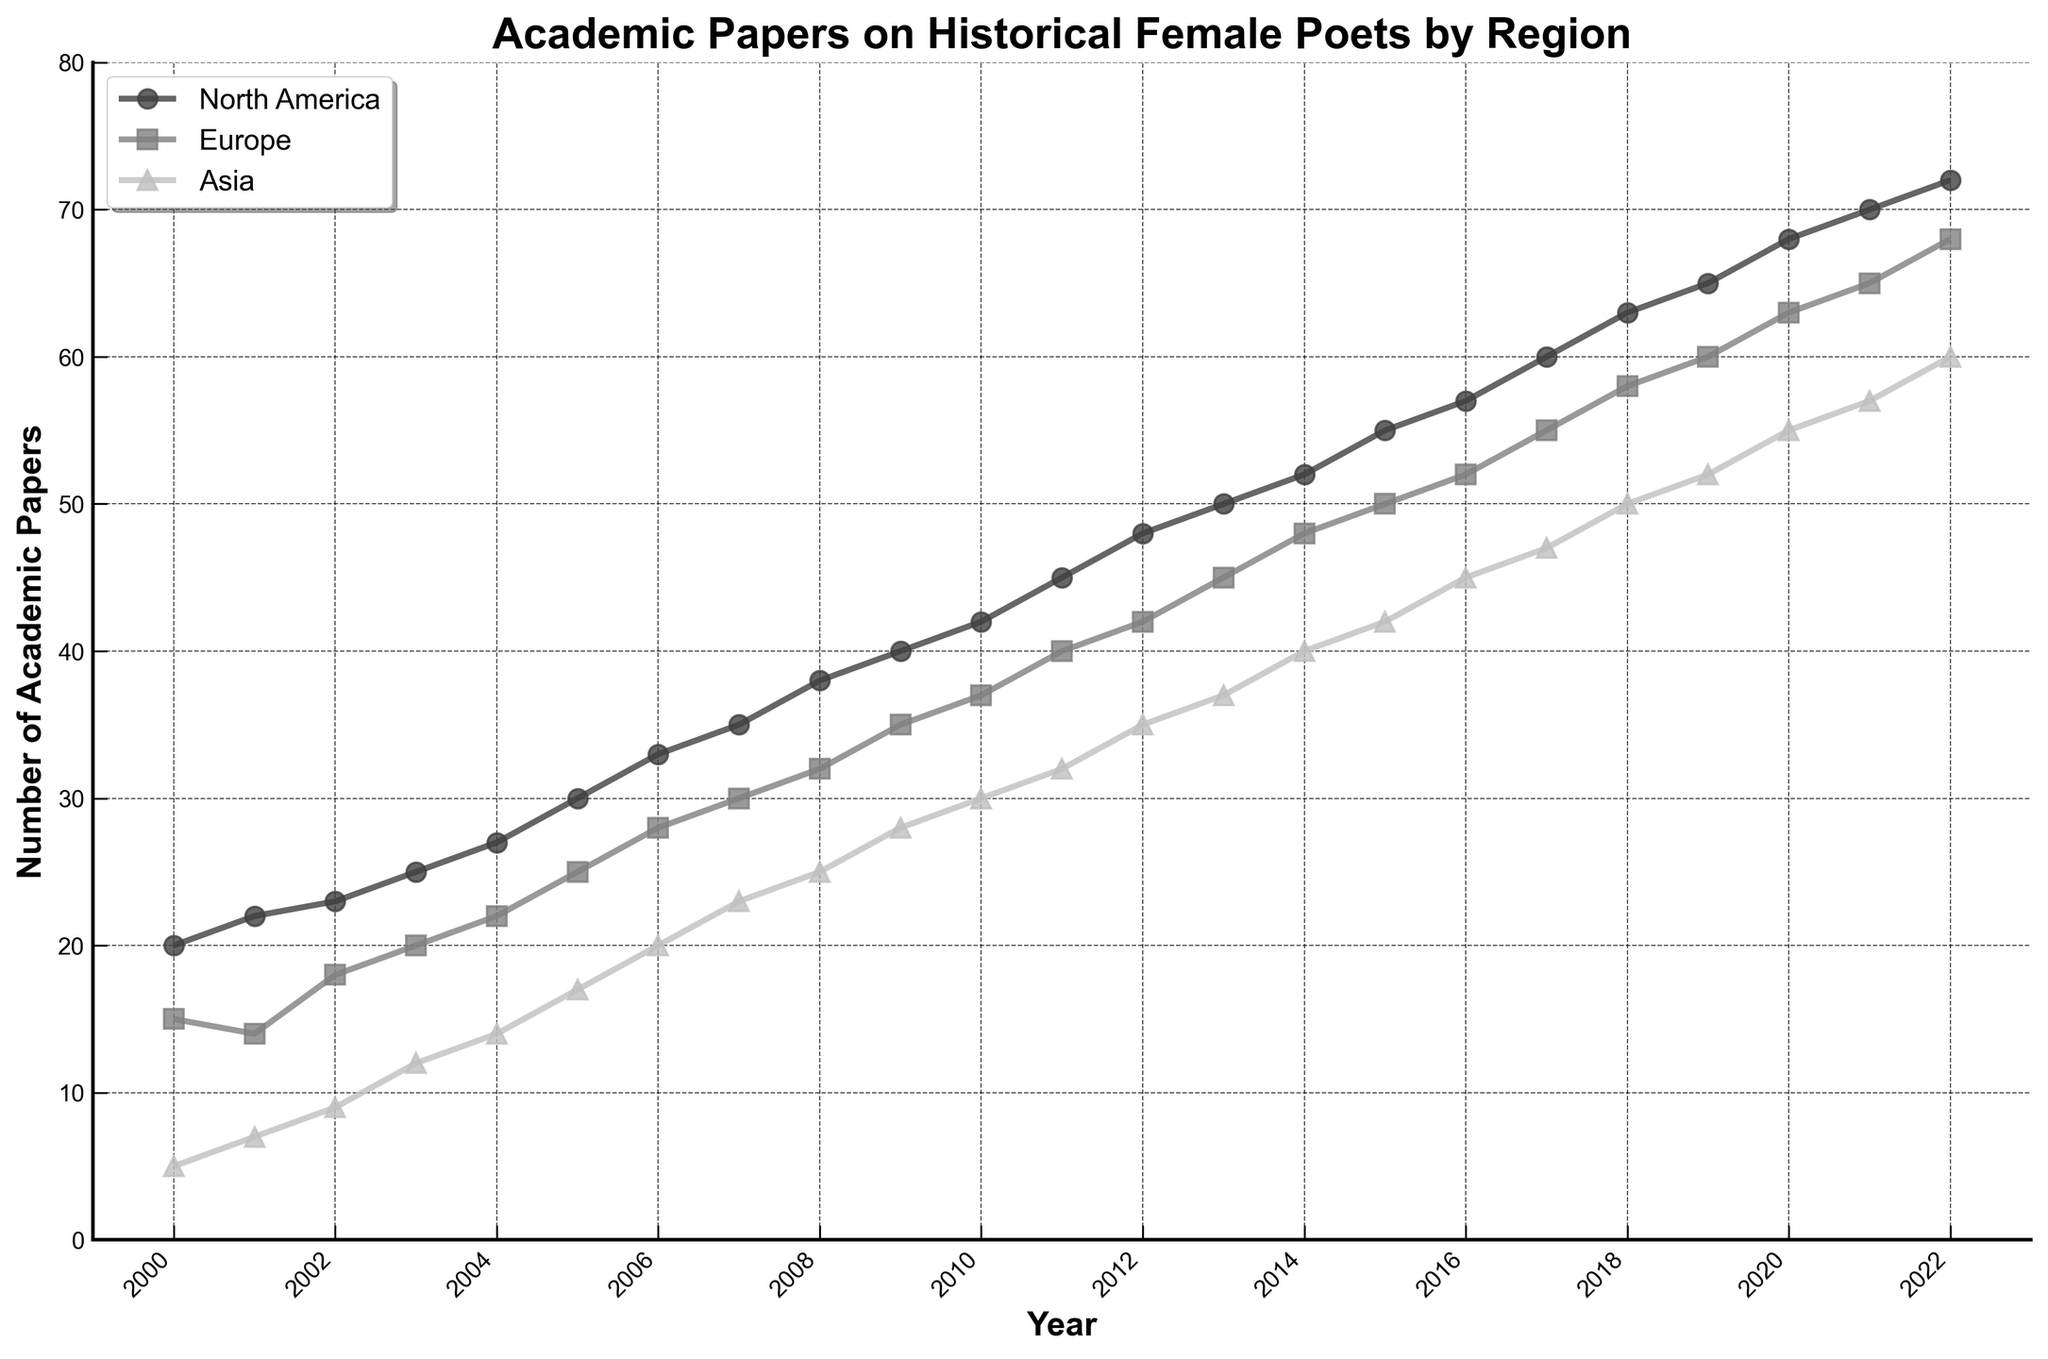What is the title of the figure? The title is usually located at the top of the figure and is meant to describe what the figure is about.
Answer: Academic Papers on Historical Female Poets by Region Which region had the highest number of published papers in 2022? To answer this, look at the data points for all regions in the year 2022 and identify the one with the highest value on the y-axis.
Answer: North America What was the trend of publications in Europe from 2000 to 2022? Analyze the line representing Europe throughout the years to see if the number of publications is increasing, decreasing, or stable.
Answer: Increasing How many academic papers were published in Asia in 2011? Look at the value on the y-axis for the year 2011 for the Asia region.
Answer: 32 Which region showed the smallest increase in the number of papers between 2000 and 2022? Calculate the increase by subtracting the 2000 values from the 2022 values for all regions. Compare these increases to determine the smallest one.
Answer: Europe (53 papers) What is the difference between the number of academic papers published in North America and Asia in 2020? Find the number of publications for North America and Asia in 2020, then subtract the smaller number from the larger one to get the difference.
Answer: 13 papers Around which year did Europe surpass 30 academic papers? Identify the year in which the line representing Europe first crosses the 30 papers threshold on the y-axis.
Answer: 2007 What is common among the regions in the publication trajectories from 2000 to 2022? Identify the patterns or trends shared by the trajectories of all three regions from 2000 to 2022.
Answer: All regions show an increasing number of publications During which period did the Asian region see the most significant rise in academic papers? Look for the steepest section of the line representing Asia and note the corresponding years.
Answer: 2004-2005 Which region has the flattest line, indicating the least variability in publication rates over the observed period? Examine the slopes of the lines representing each region to determine which has the smallest variation in steepness.
Answer: Europe 